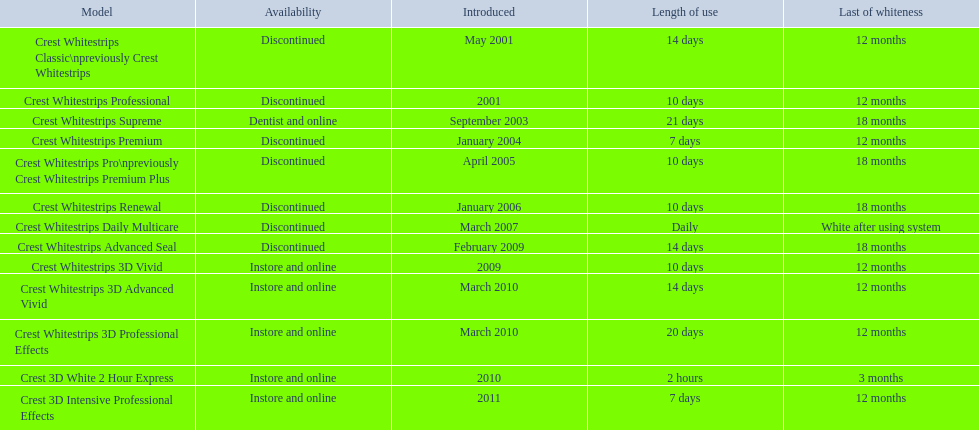What are all of the model names? Crest Whitestrips Classic\npreviously Crest Whitestrips, Crest Whitestrips Professional, Crest Whitestrips Supreme, Crest Whitestrips Premium, Crest Whitestrips Pro\npreviously Crest Whitestrips Premium Plus, Crest Whitestrips Renewal, Crest Whitestrips Daily Multicare, Crest Whitestrips Advanced Seal, Crest Whitestrips 3D Vivid, Crest Whitestrips 3D Advanced Vivid, Crest Whitestrips 3D Professional Effects, Crest 3D White 2 Hour Express, Crest 3D Intensive Professional Effects. When were they first introduced? May 2001, 2001, September 2003, January 2004, April 2005, January 2006, March 2007, February 2009, 2009, March 2010, March 2010, 2010, 2011. Along with crest whitestrips 3d advanced vivid, which other model was introduced in march 2010? Crest Whitestrips 3D Professional Effects. 